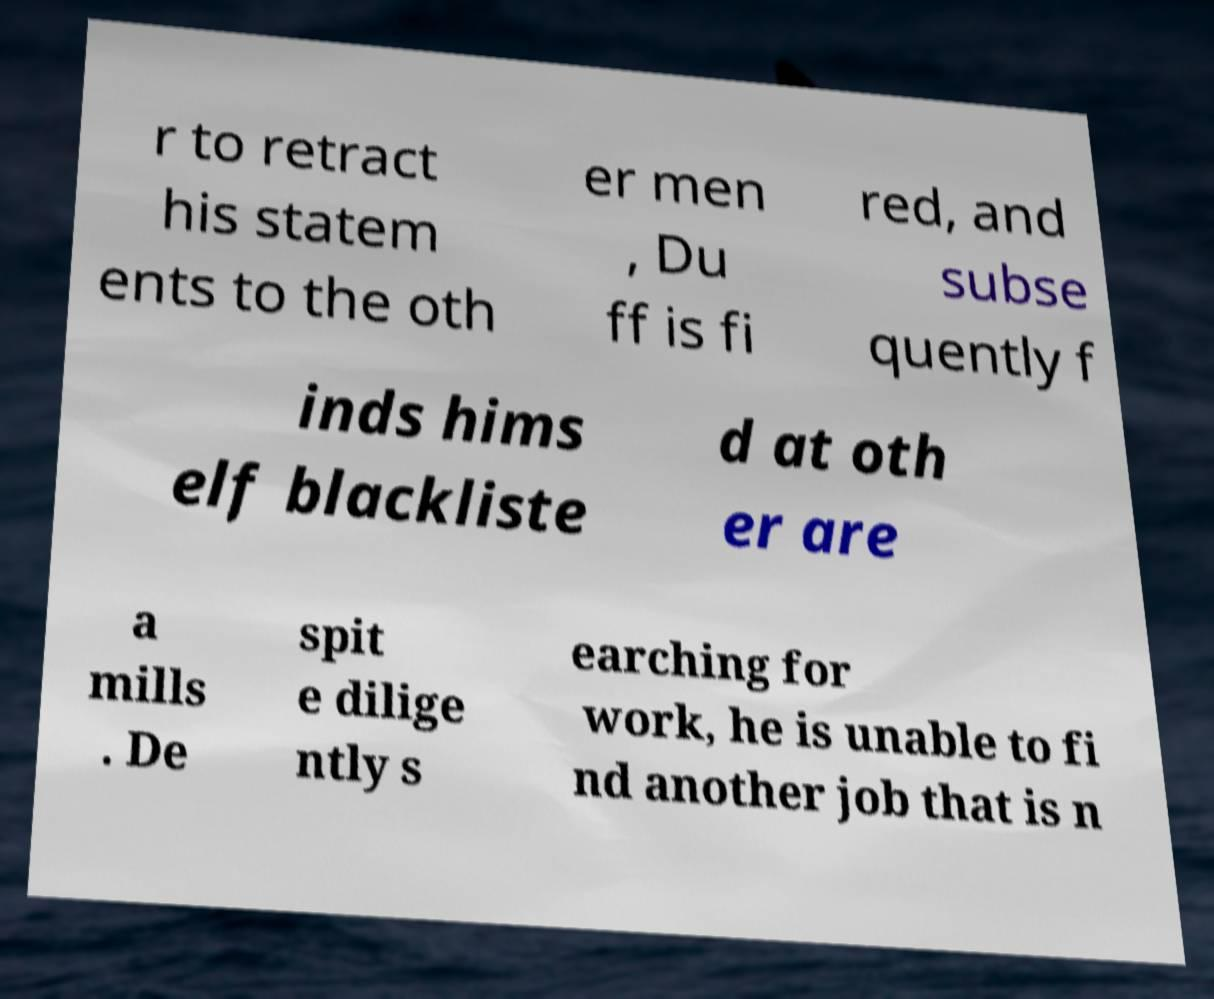Can you accurately transcribe the text from the provided image for me? r to retract his statem ents to the oth er men , Du ff is fi red, and subse quently f inds hims elf blackliste d at oth er are a mills . De spit e dilige ntly s earching for work, he is unable to fi nd another job that is n 